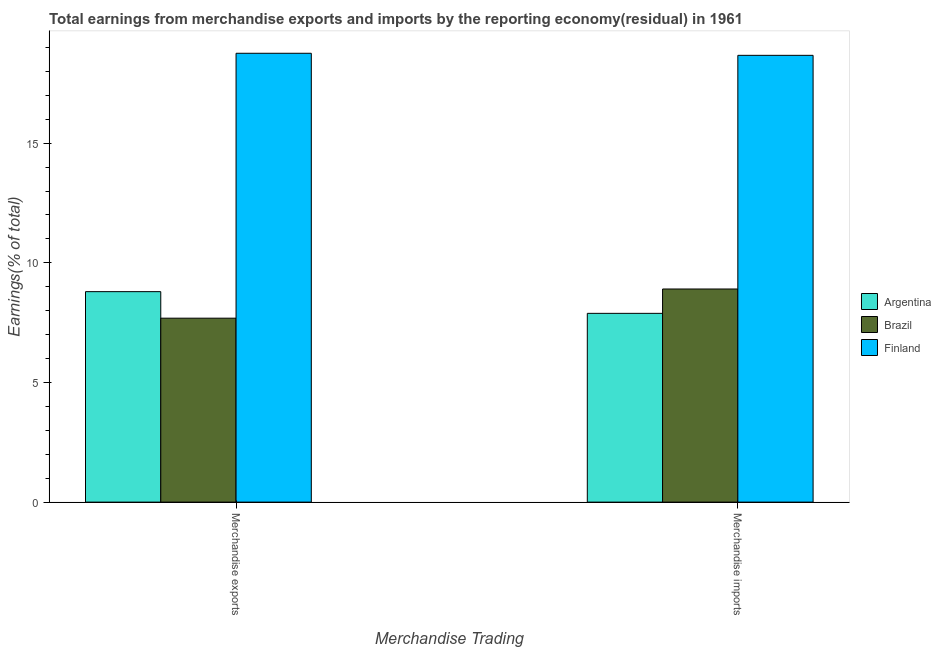Are the number of bars per tick equal to the number of legend labels?
Your answer should be compact. Yes. How many bars are there on the 2nd tick from the right?
Your answer should be very brief. 3. What is the earnings from merchandise imports in Brazil?
Your answer should be very brief. 8.91. Across all countries, what is the maximum earnings from merchandise exports?
Your response must be concise. 18.76. Across all countries, what is the minimum earnings from merchandise imports?
Ensure brevity in your answer.  7.89. In which country was the earnings from merchandise imports maximum?
Your response must be concise. Finland. What is the total earnings from merchandise exports in the graph?
Your answer should be compact. 35.24. What is the difference between the earnings from merchandise imports in Finland and that in Argentina?
Keep it short and to the point. 10.78. What is the difference between the earnings from merchandise exports in Finland and the earnings from merchandise imports in Brazil?
Make the answer very short. 9.85. What is the average earnings from merchandise imports per country?
Offer a terse response. 11.82. What is the difference between the earnings from merchandise exports and earnings from merchandise imports in Argentina?
Your answer should be very brief. 0.91. What is the ratio of the earnings from merchandise exports in Argentina to that in Brazil?
Your response must be concise. 1.14. What does the 2nd bar from the left in Merchandise exports represents?
Offer a terse response. Brazil. What does the 3rd bar from the right in Merchandise exports represents?
Your answer should be compact. Argentina. How many countries are there in the graph?
Make the answer very short. 3. What is the difference between two consecutive major ticks on the Y-axis?
Your answer should be very brief. 5. Are the values on the major ticks of Y-axis written in scientific E-notation?
Offer a very short reply. No. Where does the legend appear in the graph?
Your answer should be very brief. Center right. How many legend labels are there?
Make the answer very short. 3. How are the legend labels stacked?
Keep it short and to the point. Vertical. What is the title of the graph?
Your answer should be compact. Total earnings from merchandise exports and imports by the reporting economy(residual) in 1961. Does "Angola" appear as one of the legend labels in the graph?
Provide a succinct answer. No. What is the label or title of the X-axis?
Your answer should be compact. Merchandise Trading. What is the label or title of the Y-axis?
Give a very brief answer. Earnings(% of total). What is the Earnings(% of total) in Argentina in Merchandise exports?
Provide a short and direct response. 8.79. What is the Earnings(% of total) of Brazil in Merchandise exports?
Provide a succinct answer. 7.69. What is the Earnings(% of total) of Finland in Merchandise exports?
Your response must be concise. 18.76. What is the Earnings(% of total) of Argentina in Merchandise imports?
Make the answer very short. 7.89. What is the Earnings(% of total) in Brazil in Merchandise imports?
Your response must be concise. 8.91. What is the Earnings(% of total) in Finland in Merchandise imports?
Your answer should be very brief. 18.67. Across all Merchandise Trading, what is the maximum Earnings(% of total) in Argentina?
Provide a succinct answer. 8.79. Across all Merchandise Trading, what is the maximum Earnings(% of total) of Brazil?
Offer a terse response. 8.91. Across all Merchandise Trading, what is the maximum Earnings(% of total) in Finland?
Your response must be concise. 18.76. Across all Merchandise Trading, what is the minimum Earnings(% of total) of Argentina?
Your answer should be compact. 7.89. Across all Merchandise Trading, what is the minimum Earnings(% of total) of Brazil?
Your answer should be very brief. 7.69. Across all Merchandise Trading, what is the minimum Earnings(% of total) in Finland?
Offer a terse response. 18.67. What is the total Earnings(% of total) in Argentina in the graph?
Keep it short and to the point. 16.68. What is the total Earnings(% of total) in Brazil in the graph?
Make the answer very short. 16.59. What is the total Earnings(% of total) in Finland in the graph?
Offer a very short reply. 37.43. What is the difference between the Earnings(% of total) of Argentina in Merchandise exports and that in Merchandise imports?
Keep it short and to the point. 0.91. What is the difference between the Earnings(% of total) of Brazil in Merchandise exports and that in Merchandise imports?
Ensure brevity in your answer.  -1.22. What is the difference between the Earnings(% of total) of Finland in Merchandise exports and that in Merchandise imports?
Give a very brief answer. 0.09. What is the difference between the Earnings(% of total) in Argentina in Merchandise exports and the Earnings(% of total) in Brazil in Merchandise imports?
Make the answer very short. -0.11. What is the difference between the Earnings(% of total) of Argentina in Merchandise exports and the Earnings(% of total) of Finland in Merchandise imports?
Offer a terse response. -9.88. What is the difference between the Earnings(% of total) of Brazil in Merchandise exports and the Earnings(% of total) of Finland in Merchandise imports?
Give a very brief answer. -10.98. What is the average Earnings(% of total) of Argentina per Merchandise Trading?
Keep it short and to the point. 8.34. What is the average Earnings(% of total) of Brazil per Merchandise Trading?
Provide a short and direct response. 8.3. What is the average Earnings(% of total) in Finland per Merchandise Trading?
Your response must be concise. 18.71. What is the difference between the Earnings(% of total) of Argentina and Earnings(% of total) of Brazil in Merchandise exports?
Keep it short and to the point. 1.11. What is the difference between the Earnings(% of total) in Argentina and Earnings(% of total) in Finland in Merchandise exports?
Keep it short and to the point. -9.96. What is the difference between the Earnings(% of total) of Brazil and Earnings(% of total) of Finland in Merchandise exports?
Offer a terse response. -11.07. What is the difference between the Earnings(% of total) in Argentina and Earnings(% of total) in Brazil in Merchandise imports?
Ensure brevity in your answer.  -1.02. What is the difference between the Earnings(% of total) in Argentina and Earnings(% of total) in Finland in Merchandise imports?
Your answer should be very brief. -10.78. What is the difference between the Earnings(% of total) in Brazil and Earnings(% of total) in Finland in Merchandise imports?
Offer a very short reply. -9.76. What is the ratio of the Earnings(% of total) of Argentina in Merchandise exports to that in Merchandise imports?
Your answer should be very brief. 1.11. What is the ratio of the Earnings(% of total) in Brazil in Merchandise exports to that in Merchandise imports?
Provide a succinct answer. 0.86. What is the difference between the highest and the second highest Earnings(% of total) of Argentina?
Your answer should be very brief. 0.91. What is the difference between the highest and the second highest Earnings(% of total) in Brazil?
Your answer should be compact. 1.22. What is the difference between the highest and the second highest Earnings(% of total) of Finland?
Provide a succinct answer. 0.09. What is the difference between the highest and the lowest Earnings(% of total) in Argentina?
Your response must be concise. 0.91. What is the difference between the highest and the lowest Earnings(% of total) of Brazil?
Offer a terse response. 1.22. What is the difference between the highest and the lowest Earnings(% of total) in Finland?
Give a very brief answer. 0.09. 